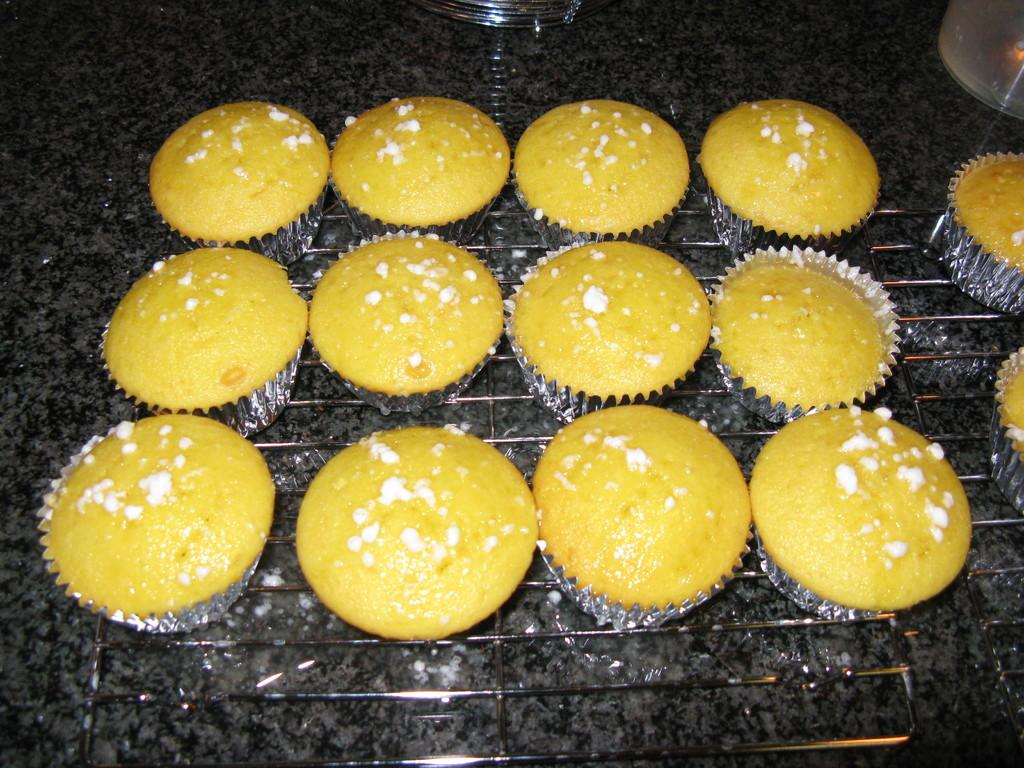What type of baked goods can be seen in the image? There are cupcakes in the image. Where are the cupcakes located? The cupcakes are on a baking grill. What is the price of the frog sitting next to the cupcakes in the image? There is no frog present in the image, and therefore no price can be determined. 